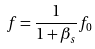<formula> <loc_0><loc_0><loc_500><loc_500>f = { \frac { 1 } { 1 + \beta _ { s } } } f _ { 0 }</formula> 